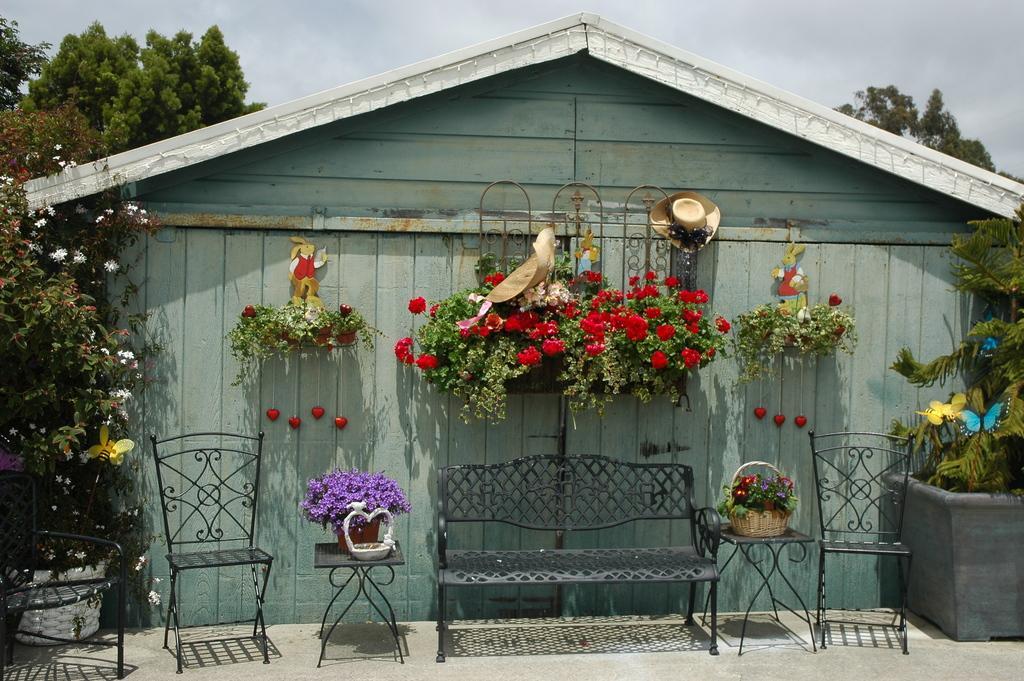Can you describe this image briefly? In this image I see a house over here and I see the chairs and a bench over here and I see the stools on which there are flowers and I see the plants on which there are few more flowers and I see the trees. In the background I see the cloudy sky. 